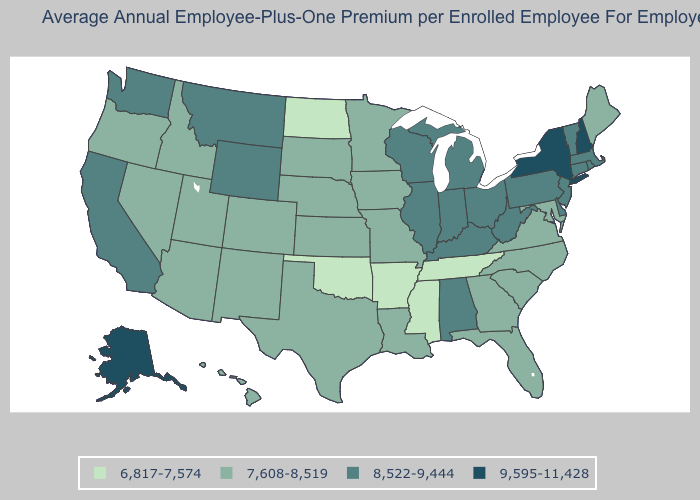Name the states that have a value in the range 9,595-11,428?
Give a very brief answer. Alaska, New Hampshire, New York. Which states have the lowest value in the USA?
Be succinct. Arkansas, Mississippi, North Dakota, Oklahoma, Tennessee. Among the states that border Delaware , does New Jersey have the lowest value?
Answer briefly. No. Name the states that have a value in the range 6,817-7,574?
Concise answer only. Arkansas, Mississippi, North Dakota, Oklahoma, Tennessee. Does West Virginia have the highest value in the South?
Write a very short answer. Yes. Which states have the highest value in the USA?
Be succinct. Alaska, New Hampshire, New York. What is the value of Hawaii?
Keep it brief. 7,608-8,519. Does Georgia have the highest value in the South?
Keep it brief. No. What is the highest value in states that border Iowa?
Short answer required. 8,522-9,444. What is the highest value in states that border Delaware?
Write a very short answer. 8,522-9,444. What is the value of Texas?
Give a very brief answer. 7,608-8,519. Does Rhode Island have the highest value in the USA?
Be succinct. No. Name the states that have a value in the range 8,522-9,444?
Write a very short answer. Alabama, California, Connecticut, Delaware, Illinois, Indiana, Kentucky, Massachusetts, Michigan, Montana, New Jersey, Ohio, Pennsylvania, Rhode Island, Vermont, Washington, West Virginia, Wisconsin, Wyoming. What is the value of North Dakota?
Write a very short answer. 6,817-7,574. What is the value of Colorado?
Answer briefly. 7,608-8,519. 